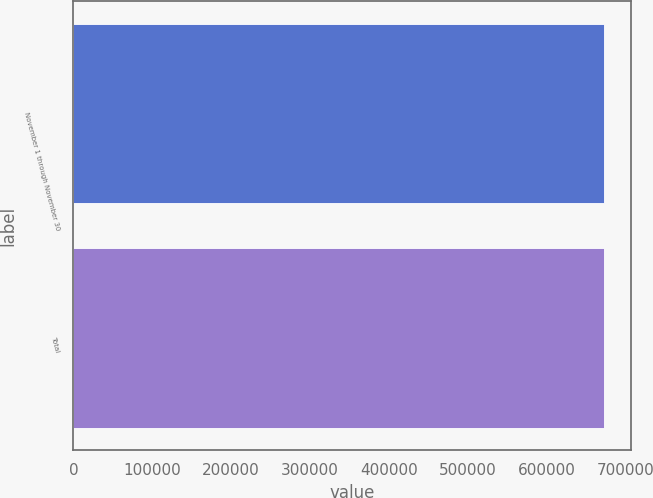Convert chart to OTSL. <chart><loc_0><loc_0><loc_500><loc_500><bar_chart><fcel>November 1 through November 30<fcel>Total<nl><fcel>672500<fcel>672500<nl></chart> 